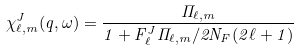Convert formula to latex. <formula><loc_0><loc_0><loc_500><loc_500>\chi _ { \ell , m } ^ { J } ( q , \omega ) = \frac { \Pi _ { \ell , m } } { 1 + F _ { \ell } ^ { J } \Pi _ { \ell , m } / 2 N _ { F } ( 2 \ell + 1 ) }</formula> 